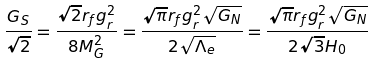Convert formula to latex. <formula><loc_0><loc_0><loc_500><loc_500>\frac { G _ { S } } { \sqrt { 2 } } = \frac { \sqrt { 2 } r _ { f } g _ { r } ^ { 2 } } { 8 M _ { G } ^ { 2 } } = \frac { \sqrt { \pi } r _ { f } g _ { r } ^ { 2 } \sqrt { G _ { N } } } { 2 \sqrt { \Lambda _ { e } } } = \frac { \sqrt { \pi } r _ { f } g _ { r } ^ { 2 } \sqrt { G _ { N } } } { 2 \sqrt { 3 } H _ { 0 } }</formula> 